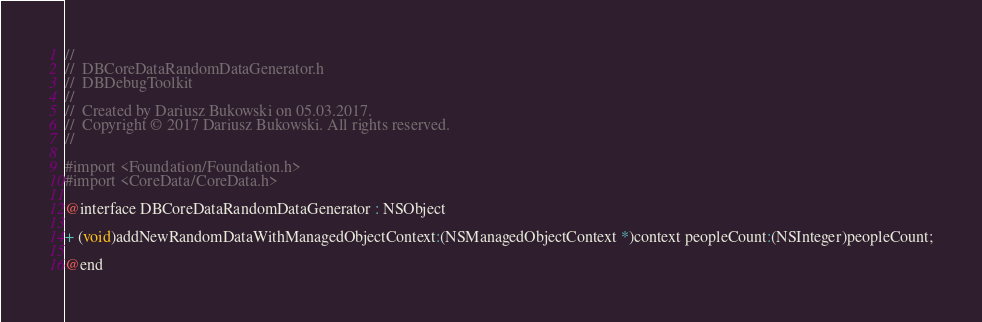<code> <loc_0><loc_0><loc_500><loc_500><_C_>//
//  DBCoreDataRandomDataGenerator.h
//  DBDebugToolkit
//
//  Created by Dariusz Bukowski on 05.03.2017.
//  Copyright © 2017 Dariusz Bukowski. All rights reserved.
//

#import <Foundation/Foundation.h>
#import <CoreData/CoreData.h>

@interface DBCoreDataRandomDataGenerator : NSObject

+ (void)addNewRandomDataWithManagedObjectContext:(NSManagedObjectContext *)context peopleCount:(NSInteger)peopleCount;

@end
</code> 